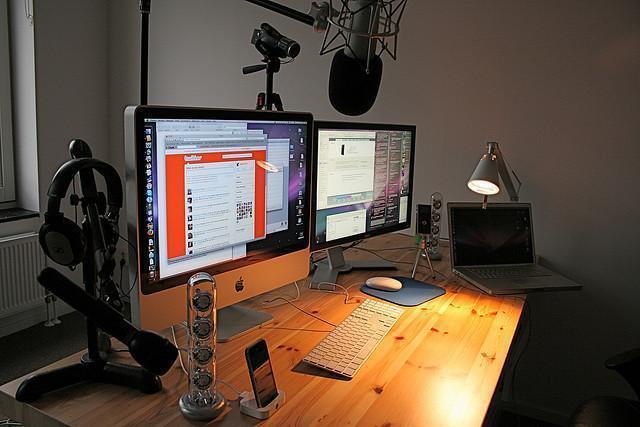What is the wooden item here?
Select the accurate answer and provide justification: `Answer: choice
Rationale: srationale.`
Options: Paddle, spoon, pirate leg, desk. Answer: desk.
Rationale: There is a table for computers here. 